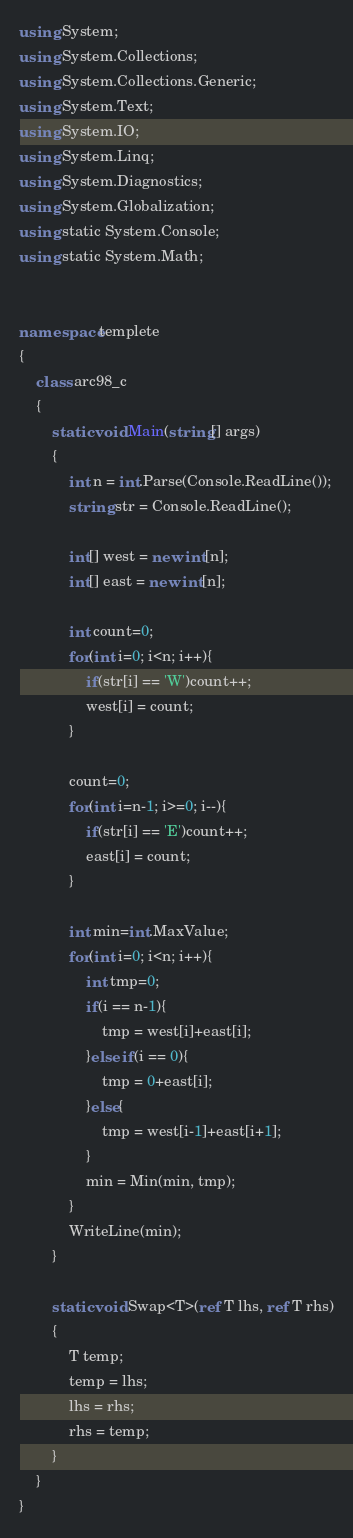Convert code to text. <code><loc_0><loc_0><loc_500><loc_500><_C#_>using System;
using System.Collections;
using System.Collections.Generic;
using System.Text;
using System.IO;
using System.Linq;
using System.Diagnostics;
using System.Globalization;
using static System.Console;
using static System.Math;


namespace templete
{
    class arc98_c
    {
        static void Main(string[] args)
        {
            int n = int.Parse(Console.ReadLine());
            string str = Console.ReadLine();

            int[] west = new int[n];
            int[] east = new int[n];

            int count=0;
            for(int i=0; i<n; i++){
                if(str[i] == 'W')count++;
                west[i] = count;
            }

            count=0;
            for(int i=n-1; i>=0; i--){
                if(str[i] == 'E')count++;
                east[i] = count;
            }

            int min=int.MaxValue;
            for(int i=0; i<n; i++){
                int tmp=0;
                if(i == n-1){
                    tmp = west[i]+east[i];
                }else if(i == 0){
                    tmp = 0+east[i];
                }else{
                    tmp = west[i-1]+east[i+1];
                }
                min = Min(min, tmp);
            }
            WriteLine(min);
        }

        static void Swap<T>(ref T lhs, ref T rhs)
        {
            T temp;
            temp = lhs;
            lhs = rhs;
            rhs = temp;
        }
    }
}</code> 